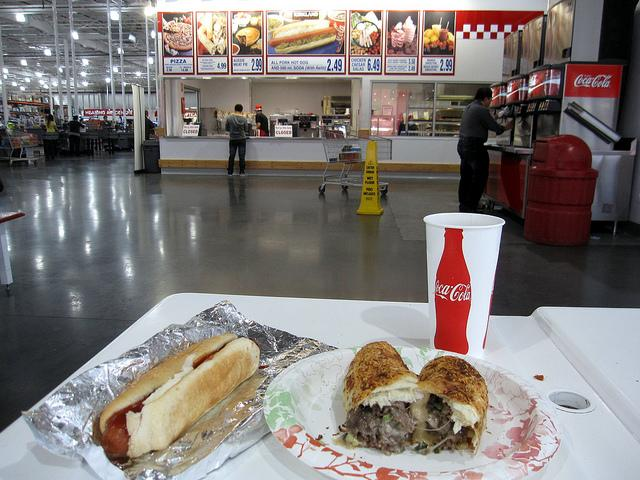Do both options have cheese on them?

Choices:
A) maybe
B) yes
C) unsure
D) no no 